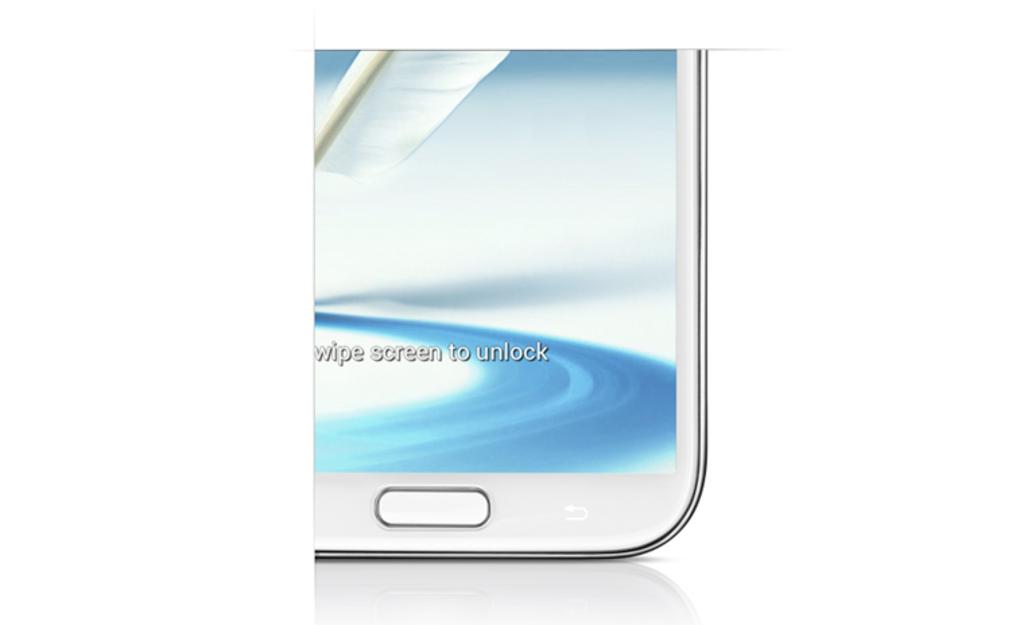Swipe screen to do what?
Ensure brevity in your answer.  Unlock. 